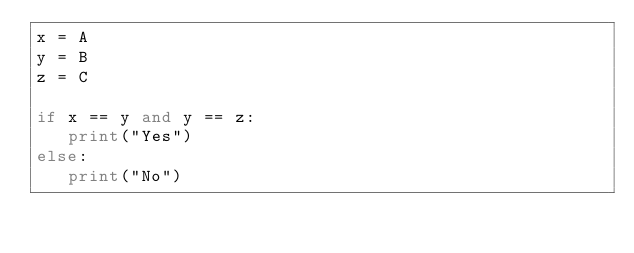<code> <loc_0><loc_0><loc_500><loc_500><_Python_>x = A
y = B
z = C

if x == y and y == z:
   print("Yes")
else:
   print("No")</code> 